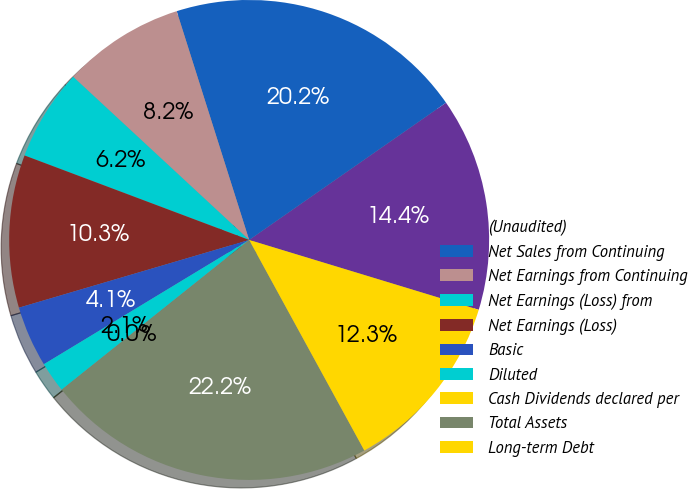<chart> <loc_0><loc_0><loc_500><loc_500><pie_chart><fcel>(Unaudited)<fcel>Net Sales from Continuing<fcel>Net Earnings from Continuing<fcel>Net Earnings (Loss) from<fcel>Net Earnings (Loss)<fcel>Basic<fcel>Diluted<fcel>Cash Dividends declared per<fcel>Total Assets<fcel>Long-term Debt<nl><fcel>14.39%<fcel>20.19%<fcel>8.22%<fcel>6.17%<fcel>10.28%<fcel>4.11%<fcel>2.06%<fcel>0.0%<fcel>22.24%<fcel>12.33%<nl></chart> 